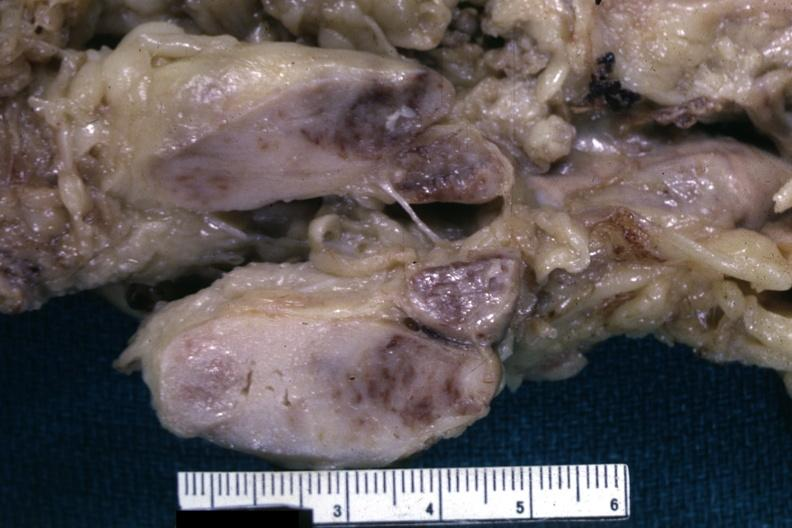what is lymphoma?
Answer the question using a single word or phrase. Liver lesion 